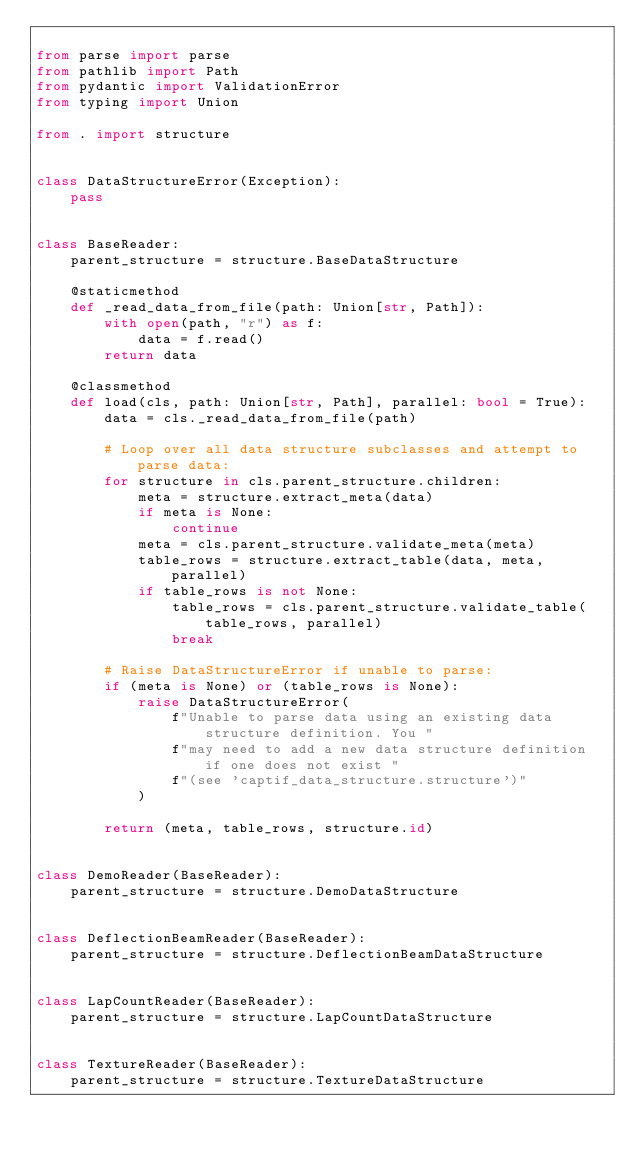Convert code to text. <code><loc_0><loc_0><loc_500><loc_500><_Python_>
from parse import parse
from pathlib import Path
from pydantic import ValidationError
from typing import Union

from . import structure


class DataStructureError(Exception):
    pass


class BaseReader:
    parent_structure = structure.BaseDataStructure

    @staticmethod
    def _read_data_from_file(path: Union[str, Path]):
        with open(path, "r") as f:
            data = f.read()
        return data

    @classmethod
    def load(cls, path: Union[str, Path], parallel: bool = True):
        data = cls._read_data_from_file(path)

        # Loop over all data structure subclasses and attempt to parse data:
        for structure in cls.parent_structure.children:
            meta = structure.extract_meta(data)
            if meta is None:
                continue
            meta = cls.parent_structure.validate_meta(meta)
            table_rows = structure.extract_table(data, meta, parallel)
            if table_rows is not None:
                table_rows = cls.parent_structure.validate_table(table_rows, parallel)
                break

        # Raise DataStructureError if unable to parse:
        if (meta is None) or (table_rows is None):
            raise DataStructureError(
                f"Unable to parse data using an existing data structure definition. You "
                f"may need to add a new data structure definition if one does not exist "
                f"(see 'captif_data_structure.structure')"
            )

        return (meta, table_rows, structure.id)


class DemoReader(BaseReader):
    parent_structure = structure.DemoDataStructure


class DeflectionBeamReader(BaseReader):
    parent_structure = structure.DeflectionBeamDataStructure


class LapCountReader(BaseReader):
    parent_structure = structure.LapCountDataStructure


class TextureReader(BaseReader):
    parent_structure = structure.TextureDataStructure
</code> 